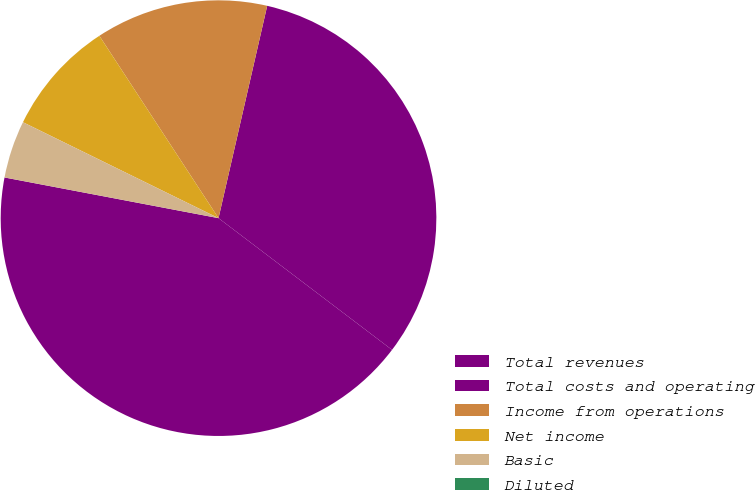<chart> <loc_0><loc_0><loc_500><loc_500><pie_chart><fcel>Total revenues<fcel>Total costs and operating<fcel>Income from operations<fcel>Net income<fcel>Basic<fcel>Diluted<nl><fcel>42.66%<fcel>31.75%<fcel>12.8%<fcel>8.53%<fcel>4.27%<fcel>0.0%<nl></chart> 